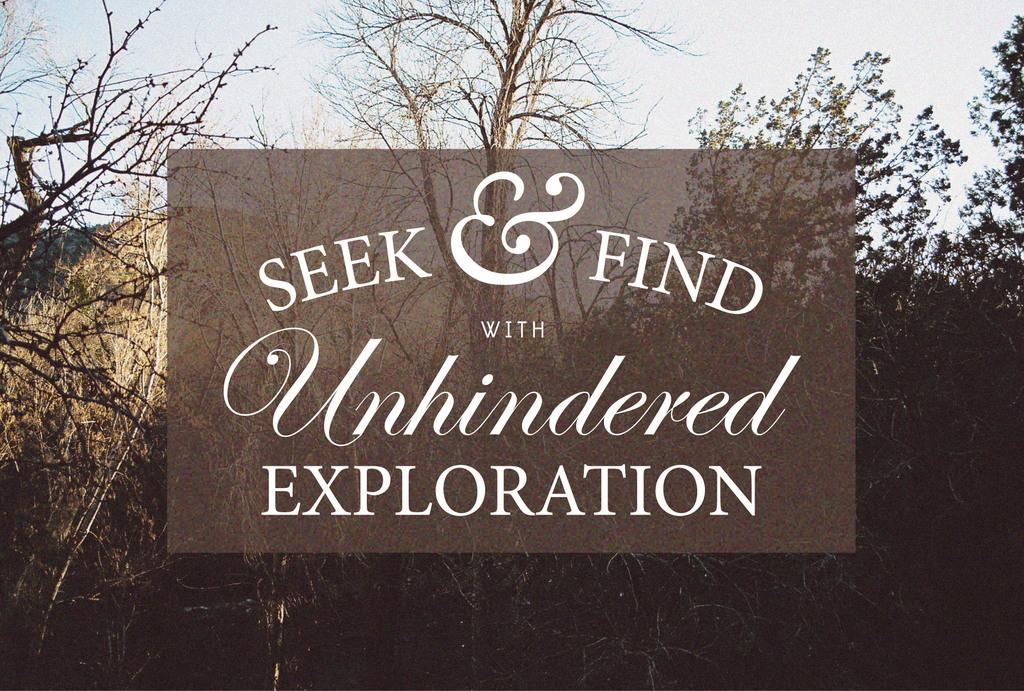What can be found in the image that contains information or a message? There is text in the image. What is the color of the background in the image? The background color is brown. What type of natural elements can be seen in the background of the image? There are trees in the background of the image. What part of the natural environment is visible in the background of the image? The sky is visible in the background of the image. What type of writing instrument is used to create the text in the image? There is no indication of the writing instrument used to create the text in the image. Additionally, the image does not show a quill, which is a specific type of writing instrument. 